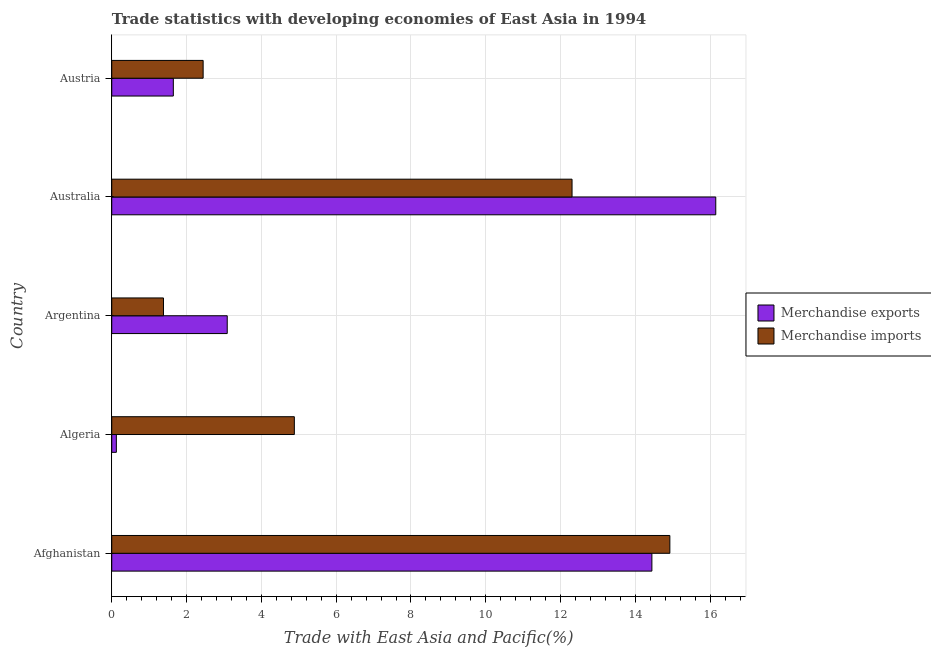How many different coloured bars are there?
Your response must be concise. 2. How many bars are there on the 5th tick from the top?
Provide a short and direct response. 2. What is the merchandise imports in Argentina?
Your response must be concise. 1.38. Across all countries, what is the maximum merchandise imports?
Your answer should be very brief. 14.92. Across all countries, what is the minimum merchandise imports?
Your answer should be compact. 1.38. In which country was the merchandise imports maximum?
Your response must be concise. Afghanistan. What is the total merchandise exports in the graph?
Give a very brief answer. 35.45. What is the difference between the merchandise exports in Argentina and that in Australia?
Ensure brevity in your answer.  -13.06. What is the difference between the merchandise exports in Australia and the merchandise imports in Algeria?
Make the answer very short. 11.27. What is the average merchandise imports per country?
Ensure brevity in your answer.  7.19. What is the difference between the merchandise imports and merchandise exports in Australia?
Provide a short and direct response. -3.84. In how many countries, is the merchandise imports greater than 3.2 %?
Your answer should be compact. 3. What is the ratio of the merchandise exports in Australia to that in Austria?
Ensure brevity in your answer.  9.81. Is the merchandise imports in Algeria less than that in Austria?
Offer a terse response. No. Is the difference between the merchandise exports in Algeria and Australia greater than the difference between the merchandise imports in Algeria and Australia?
Make the answer very short. No. What is the difference between the highest and the second highest merchandise imports?
Your response must be concise. 2.62. What is the difference between the highest and the lowest merchandise imports?
Offer a terse response. 13.54. Is the sum of the merchandise imports in Afghanistan and Australia greater than the maximum merchandise exports across all countries?
Your answer should be compact. Yes. What does the 2nd bar from the top in Algeria represents?
Your answer should be very brief. Merchandise exports. What does the 2nd bar from the bottom in Austria represents?
Make the answer very short. Merchandise imports. Are all the bars in the graph horizontal?
Offer a very short reply. Yes. How many countries are there in the graph?
Your answer should be compact. 5. Are the values on the major ticks of X-axis written in scientific E-notation?
Offer a very short reply. No. Does the graph contain any zero values?
Keep it short and to the point. No. Where does the legend appear in the graph?
Your answer should be very brief. Center right. How are the legend labels stacked?
Provide a succinct answer. Vertical. What is the title of the graph?
Provide a succinct answer. Trade statistics with developing economies of East Asia in 1994. What is the label or title of the X-axis?
Give a very brief answer. Trade with East Asia and Pacific(%). What is the label or title of the Y-axis?
Give a very brief answer. Country. What is the Trade with East Asia and Pacific(%) of Merchandise exports in Afghanistan?
Offer a very short reply. 14.44. What is the Trade with East Asia and Pacific(%) of Merchandise imports in Afghanistan?
Your answer should be compact. 14.92. What is the Trade with East Asia and Pacific(%) of Merchandise exports in Algeria?
Your answer should be compact. 0.12. What is the Trade with East Asia and Pacific(%) of Merchandise imports in Algeria?
Make the answer very short. 4.88. What is the Trade with East Asia and Pacific(%) in Merchandise exports in Argentina?
Provide a succinct answer. 3.09. What is the Trade with East Asia and Pacific(%) in Merchandise imports in Argentina?
Give a very brief answer. 1.38. What is the Trade with East Asia and Pacific(%) of Merchandise exports in Australia?
Offer a terse response. 16.15. What is the Trade with East Asia and Pacific(%) in Merchandise imports in Australia?
Give a very brief answer. 12.31. What is the Trade with East Asia and Pacific(%) of Merchandise exports in Austria?
Your answer should be very brief. 1.65. What is the Trade with East Asia and Pacific(%) of Merchandise imports in Austria?
Ensure brevity in your answer.  2.44. Across all countries, what is the maximum Trade with East Asia and Pacific(%) in Merchandise exports?
Give a very brief answer. 16.15. Across all countries, what is the maximum Trade with East Asia and Pacific(%) of Merchandise imports?
Make the answer very short. 14.92. Across all countries, what is the minimum Trade with East Asia and Pacific(%) of Merchandise exports?
Your answer should be very brief. 0.12. Across all countries, what is the minimum Trade with East Asia and Pacific(%) of Merchandise imports?
Make the answer very short. 1.38. What is the total Trade with East Asia and Pacific(%) of Merchandise exports in the graph?
Your answer should be very brief. 35.45. What is the total Trade with East Asia and Pacific(%) in Merchandise imports in the graph?
Provide a succinct answer. 35.94. What is the difference between the Trade with East Asia and Pacific(%) in Merchandise exports in Afghanistan and that in Algeria?
Give a very brief answer. 14.32. What is the difference between the Trade with East Asia and Pacific(%) of Merchandise imports in Afghanistan and that in Algeria?
Your answer should be compact. 10.04. What is the difference between the Trade with East Asia and Pacific(%) of Merchandise exports in Afghanistan and that in Argentina?
Offer a very short reply. 11.35. What is the difference between the Trade with East Asia and Pacific(%) of Merchandise imports in Afghanistan and that in Argentina?
Make the answer very short. 13.54. What is the difference between the Trade with East Asia and Pacific(%) in Merchandise exports in Afghanistan and that in Australia?
Offer a very short reply. -1.71. What is the difference between the Trade with East Asia and Pacific(%) in Merchandise imports in Afghanistan and that in Australia?
Provide a succinct answer. 2.62. What is the difference between the Trade with East Asia and Pacific(%) in Merchandise exports in Afghanistan and that in Austria?
Ensure brevity in your answer.  12.8. What is the difference between the Trade with East Asia and Pacific(%) of Merchandise imports in Afghanistan and that in Austria?
Offer a very short reply. 12.48. What is the difference between the Trade with East Asia and Pacific(%) of Merchandise exports in Algeria and that in Argentina?
Make the answer very short. -2.96. What is the difference between the Trade with East Asia and Pacific(%) in Merchandise imports in Algeria and that in Argentina?
Your answer should be compact. 3.5. What is the difference between the Trade with East Asia and Pacific(%) of Merchandise exports in Algeria and that in Australia?
Offer a very short reply. -16.03. What is the difference between the Trade with East Asia and Pacific(%) of Merchandise imports in Algeria and that in Australia?
Ensure brevity in your answer.  -7.43. What is the difference between the Trade with East Asia and Pacific(%) of Merchandise exports in Algeria and that in Austria?
Your answer should be compact. -1.52. What is the difference between the Trade with East Asia and Pacific(%) in Merchandise imports in Algeria and that in Austria?
Offer a very short reply. 2.44. What is the difference between the Trade with East Asia and Pacific(%) of Merchandise exports in Argentina and that in Australia?
Your response must be concise. -13.06. What is the difference between the Trade with East Asia and Pacific(%) of Merchandise imports in Argentina and that in Australia?
Ensure brevity in your answer.  -10.92. What is the difference between the Trade with East Asia and Pacific(%) in Merchandise exports in Argentina and that in Austria?
Your answer should be very brief. 1.44. What is the difference between the Trade with East Asia and Pacific(%) of Merchandise imports in Argentina and that in Austria?
Offer a very short reply. -1.06. What is the difference between the Trade with East Asia and Pacific(%) in Merchandise exports in Australia and that in Austria?
Your answer should be compact. 14.5. What is the difference between the Trade with East Asia and Pacific(%) in Merchandise imports in Australia and that in Austria?
Give a very brief answer. 9.86. What is the difference between the Trade with East Asia and Pacific(%) of Merchandise exports in Afghanistan and the Trade with East Asia and Pacific(%) of Merchandise imports in Algeria?
Your answer should be very brief. 9.56. What is the difference between the Trade with East Asia and Pacific(%) of Merchandise exports in Afghanistan and the Trade with East Asia and Pacific(%) of Merchandise imports in Argentina?
Ensure brevity in your answer.  13.06. What is the difference between the Trade with East Asia and Pacific(%) in Merchandise exports in Afghanistan and the Trade with East Asia and Pacific(%) in Merchandise imports in Australia?
Provide a short and direct response. 2.13. What is the difference between the Trade with East Asia and Pacific(%) of Merchandise exports in Afghanistan and the Trade with East Asia and Pacific(%) of Merchandise imports in Austria?
Ensure brevity in your answer.  12. What is the difference between the Trade with East Asia and Pacific(%) of Merchandise exports in Algeria and the Trade with East Asia and Pacific(%) of Merchandise imports in Argentina?
Offer a very short reply. -1.26. What is the difference between the Trade with East Asia and Pacific(%) of Merchandise exports in Algeria and the Trade with East Asia and Pacific(%) of Merchandise imports in Australia?
Your answer should be very brief. -12.18. What is the difference between the Trade with East Asia and Pacific(%) in Merchandise exports in Algeria and the Trade with East Asia and Pacific(%) in Merchandise imports in Austria?
Your answer should be compact. -2.32. What is the difference between the Trade with East Asia and Pacific(%) of Merchandise exports in Argentina and the Trade with East Asia and Pacific(%) of Merchandise imports in Australia?
Keep it short and to the point. -9.22. What is the difference between the Trade with East Asia and Pacific(%) of Merchandise exports in Argentina and the Trade with East Asia and Pacific(%) of Merchandise imports in Austria?
Your response must be concise. 0.64. What is the difference between the Trade with East Asia and Pacific(%) of Merchandise exports in Australia and the Trade with East Asia and Pacific(%) of Merchandise imports in Austria?
Give a very brief answer. 13.71. What is the average Trade with East Asia and Pacific(%) in Merchandise exports per country?
Your answer should be compact. 7.09. What is the average Trade with East Asia and Pacific(%) of Merchandise imports per country?
Give a very brief answer. 7.19. What is the difference between the Trade with East Asia and Pacific(%) of Merchandise exports and Trade with East Asia and Pacific(%) of Merchandise imports in Afghanistan?
Keep it short and to the point. -0.48. What is the difference between the Trade with East Asia and Pacific(%) of Merchandise exports and Trade with East Asia and Pacific(%) of Merchandise imports in Algeria?
Your answer should be very brief. -4.76. What is the difference between the Trade with East Asia and Pacific(%) in Merchandise exports and Trade with East Asia and Pacific(%) in Merchandise imports in Argentina?
Give a very brief answer. 1.7. What is the difference between the Trade with East Asia and Pacific(%) in Merchandise exports and Trade with East Asia and Pacific(%) in Merchandise imports in Australia?
Ensure brevity in your answer.  3.84. What is the difference between the Trade with East Asia and Pacific(%) in Merchandise exports and Trade with East Asia and Pacific(%) in Merchandise imports in Austria?
Your answer should be compact. -0.8. What is the ratio of the Trade with East Asia and Pacific(%) of Merchandise exports in Afghanistan to that in Algeria?
Your answer should be very brief. 117.24. What is the ratio of the Trade with East Asia and Pacific(%) in Merchandise imports in Afghanistan to that in Algeria?
Keep it short and to the point. 3.06. What is the ratio of the Trade with East Asia and Pacific(%) of Merchandise exports in Afghanistan to that in Argentina?
Provide a short and direct response. 4.68. What is the ratio of the Trade with East Asia and Pacific(%) of Merchandise imports in Afghanistan to that in Argentina?
Your answer should be compact. 10.79. What is the ratio of the Trade with East Asia and Pacific(%) of Merchandise exports in Afghanistan to that in Australia?
Offer a terse response. 0.89. What is the ratio of the Trade with East Asia and Pacific(%) in Merchandise imports in Afghanistan to that in Australia?
Your answer should be very brief. 1.21. What is the ratio of the Trade with East Asia and Pacific(%) of Merchandise exports in Afghanistan to that in Austria?
Your answer should be very brief. 8.77. What is the ratio of the Trade with East Asia and Pacific(%) of Merchandise imports in Afghanistan to that in Austria?
Keep it short and to the point. 6.11. What is the ratio of the Trade with East Asia and Pacific(%) in Merchandise exports in Algeria to that in Argentina?
Make the answer very short. 0.04. What is the ratio of the Trade with East Asia and Pacific(%) in Merchandise imports in Algeria to that in Argentina?
Provide a short and direct response. 3.53. What is the ratio of the Trade with East Asia and Pacific(%) in Merchandise exports in Algeria to that in Australia?
Your answer should be very brief. 0.01. What is the ratio of the Trade with East Asia and Pacific(%) of Merchandise imports in Algeria to that in Australia?
Offer a very short reply. 0.4. What is the ratio of the Trade with East Asia and Pacific(%) of Merchandise exports in Algeria to that in Austria?
Your response must be concise. 0.07. What is the ratio of the Trade with East Asia and Pacific(%) of Merchandise imports in Algeria to that in Austria?
Offer a very short reply. 2. What is the ratio of the Trade with East Asia and Pacific(%) of Merchandise exports in Argentina to that in Australia?
Your answer should be compact. 0.19. What is the ratio of the Trade with East Asia and Pacific(%) in Merchandise imports in Argentina to that in Australia?
Offer a very short reply. 0.11. What is the ratio of the Trade with East Asia and Pacific(%) in Merchandise exports in Argentina to that in Austria?
Give a very brief answer. 1.88. What is the ratio of the Trade with East Asia and Pacific(%) of Merchandise imports in Argentina to that in Austria?
Give a very brief answer. 0.57. What is the ratio of the Trade with East Asia and Pacific(%) of Merchandise exports in Australia to that in Austria?
Give a very brief answer. 9.81. What is the ratio of the Trade with East Asia and Pacific(%) in Merchandise imports in Australia to that in Austria?
Your response must be concise. 5.04. What is the difference between the highest and the second highest Trade with East Asia and Pacific(%) of Merchandise exports?
Offer a terse response. 1.71. What is the difference between the highest and the second highest Trade with East Asia and Pacific(%) of Merchandise imports?
Offer a terse response. 2.62. What is the difference between the highest and the lowest Trade with East Asia and Pacific(%) in Merchandise exports?
Your answer should be very brief. 16.03. What is the difference between the highest and the lowest Trade with East Asia and Pacific(%) of Merchandise imports?
Keep it short and to the point. 13.54. 